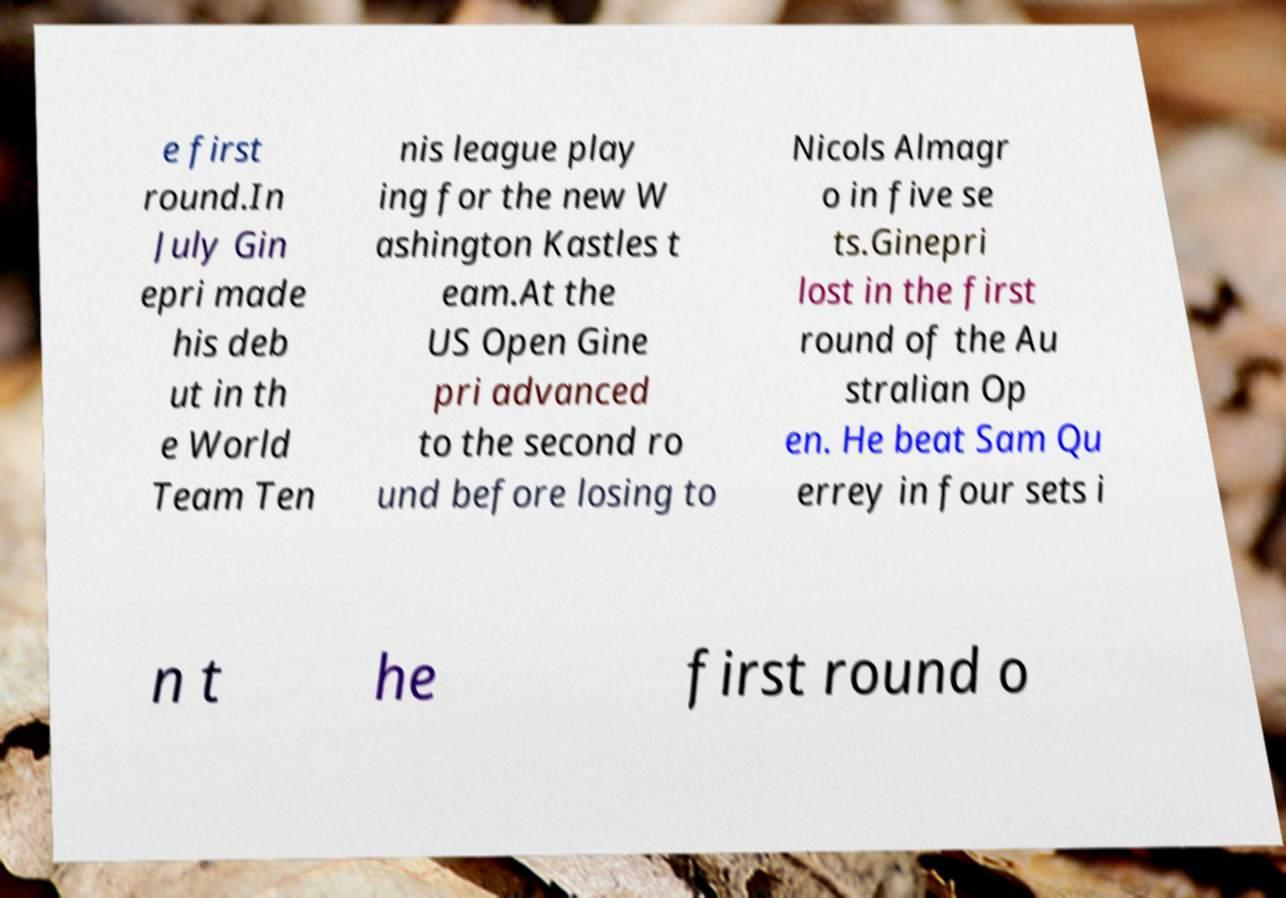I need the written content from this picture converted into text. Can you do that? e first round.In July Gin epri made his deb ut in th e World Team Ten nis league play ing for the new W ashington Kastles t eam.At the US Open Gine pri advanced to the second ro und before losing to Nicols Almagr o in five se ts.Ginepri lost in the first round of the Au stralian Op en. He beat Sam Qu errey in four sets i n t he first round o 